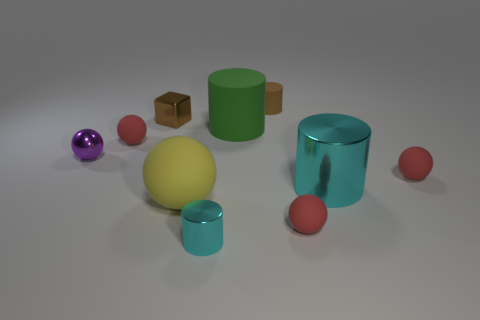Subtract all red spheres. How many were subtracted if there are2red spheres left? 1 Subtract all purple cylinders. How many red balls are left? 3 Subtract 1 cylinders. How many cylinders are left? 3 Subtract all green cylinders. How many cylinders are left? 3 Subtract all yellow matte spheres. How many spheres are left? 4 Subtract all gray cylinders. Subtract all brown balls. How many cylinders are left? 4 Subtract all blocks. How many objects are left? 9 Subtract 0 red blocks. How many objects are left? 10 Subtract all purple objects. Subtract all cyan shiny things. How many objects are left? 7 Add 2 small brown metallic things. How many small brown metallic things are left? 3 